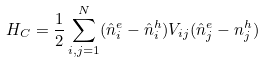Convert formula to latex. <formula><loc_0><loc_0><loc_500><loc_500>H _ { C } = \frac { 1 } { 2 } \sum _ { i , j = 1 } ^ { N } ( \hat { n } _ { i } ^ { e } - \hat { n } _ { i } ^ { h } ) V _ { i j } ( \hat { n } _ { j } ^ { e } - n _ { j } ^ { h } )</formula> 